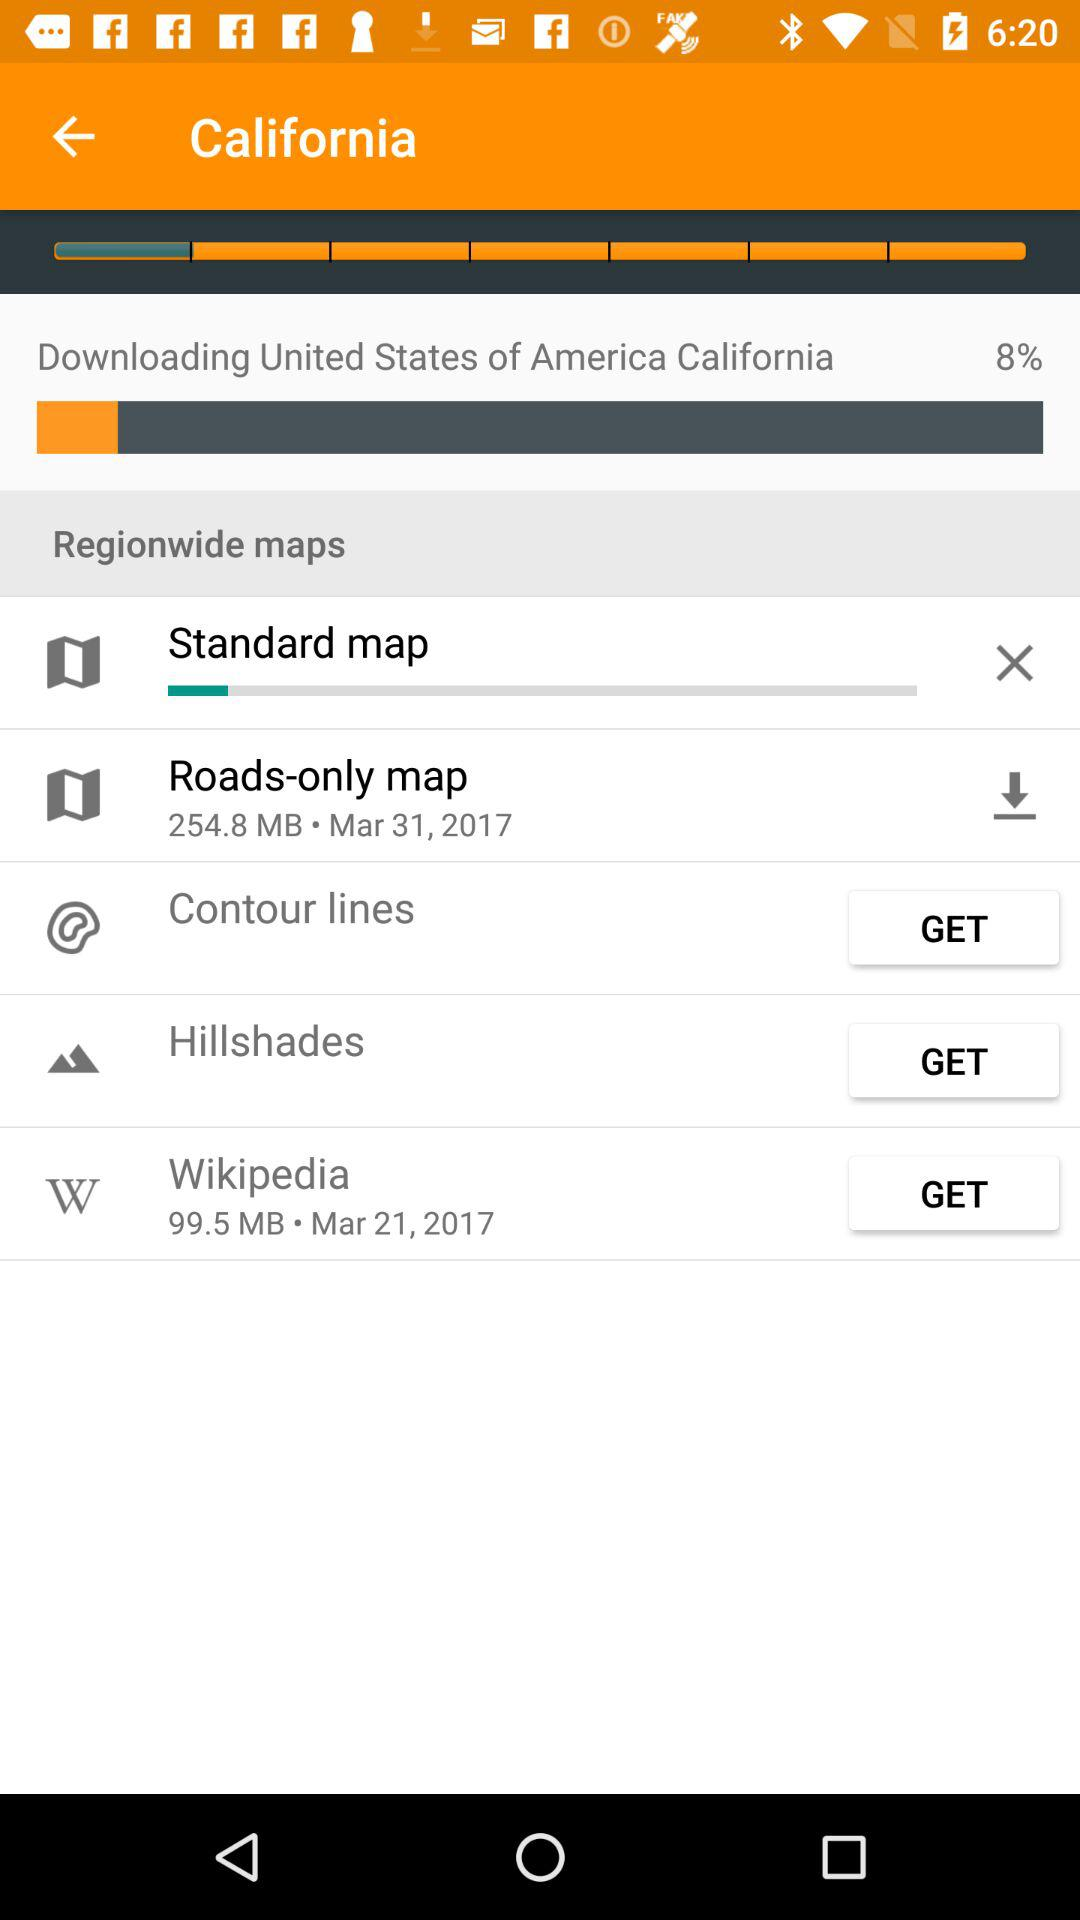What is the date to download wikipedia?
When the provided information is insufficient, respond with <no answer>. <no answer> 